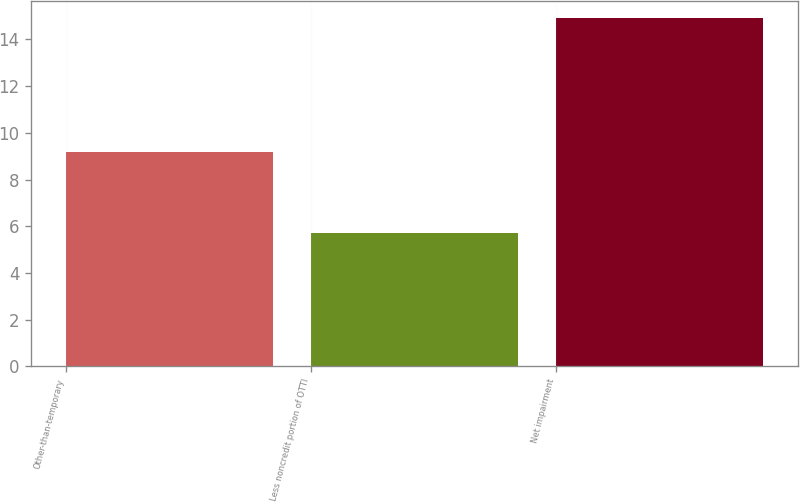<chart> <loc_0><loc_0><loc_500><loc_500><bar_chart><fcel>Other-than-temporary<fcel>Less noncredit portion of OTTI<fcel>Net impairment<nl><fcel>9.2<fcel>5.7<fcel>14.9<nl></chart> 